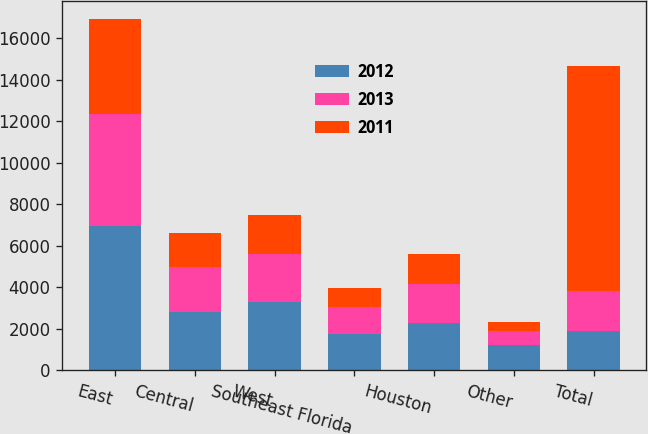Convert chart. <chart><loc_0><loc_0><loc_500><loc_500><stacked_bar_chart><ecel><fcel>East<fcel>Central<fcel>West<fcel>Southeast Florida<fcel>Houston<fcel>Other<fcel>Total<nl><fcel>2012<fcel>6941<fcel>2814<fcel>3323<fcel>1741<fcel>2266<fcel>1205<fcel>1917<nl><fcel>2013<fcel>5440<fcel>2154<fcel>2301<fcel>1314<fcel>1917<fcel>676<fcel>1917<nl><fcel>2011<fcel>4576<fcel>1661<fcel>1846<fcel>904<fcel>1411<fcel>447<fcel>10845<nl></chart> 